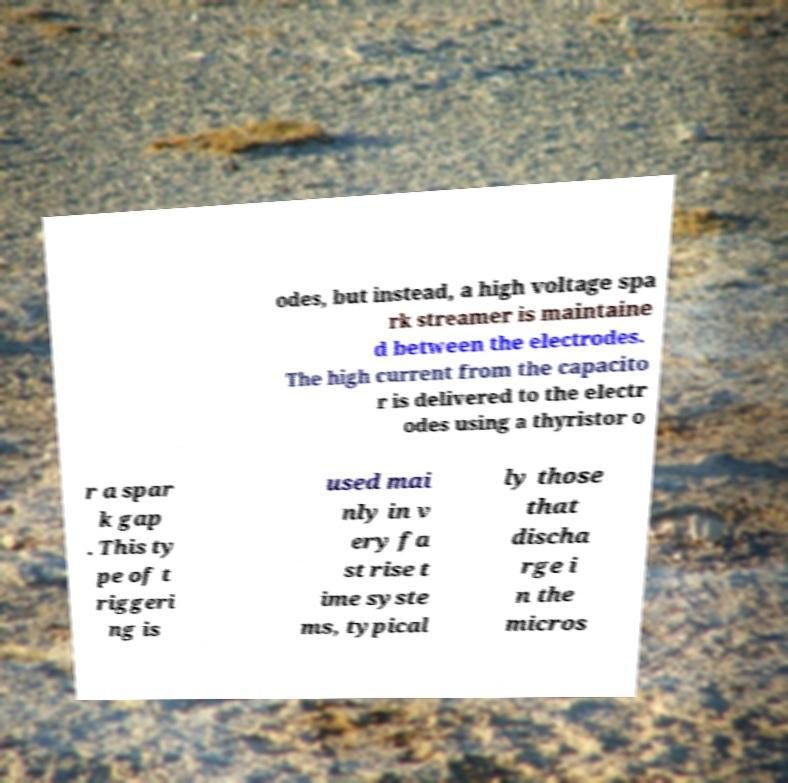Can you accurately transcribe the text from the provided image for me? odes, but instead, a high voltage spa rk streamer is maintaine d between the electrodes. The high current from the capacito r is delivered to the electr odes using a thyristor o r a spar k gap . This ty pe of t riggeri ng is used mai nly in v ery fa st rise t ime syste ms, typical ly those that discha rge i n the micros 